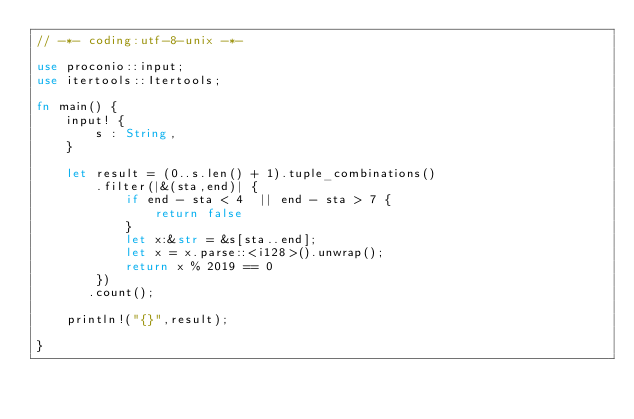Convert code to text. <code><loc_0><loc_0><loc_500><loc_500><_Rust_>// -*- coding:utf-8-unix -*-

use proconio::input;
use itertools::Itertools;

fn main() {
    input! {
        s : String,
    }

    let result = (0..s.len() + 1).tuple_combinations()
        .filter(|&(sta,end)| {
            if end - sta < 4  || end - sta > 7 {
                return false
            }
            let x:&str = &s[sta..end];
            let x = x.parse::<i128>().unwrap();
            return x % 2019 == 0    
        })
       .count();

    println!("{}",result);

}
</code> 